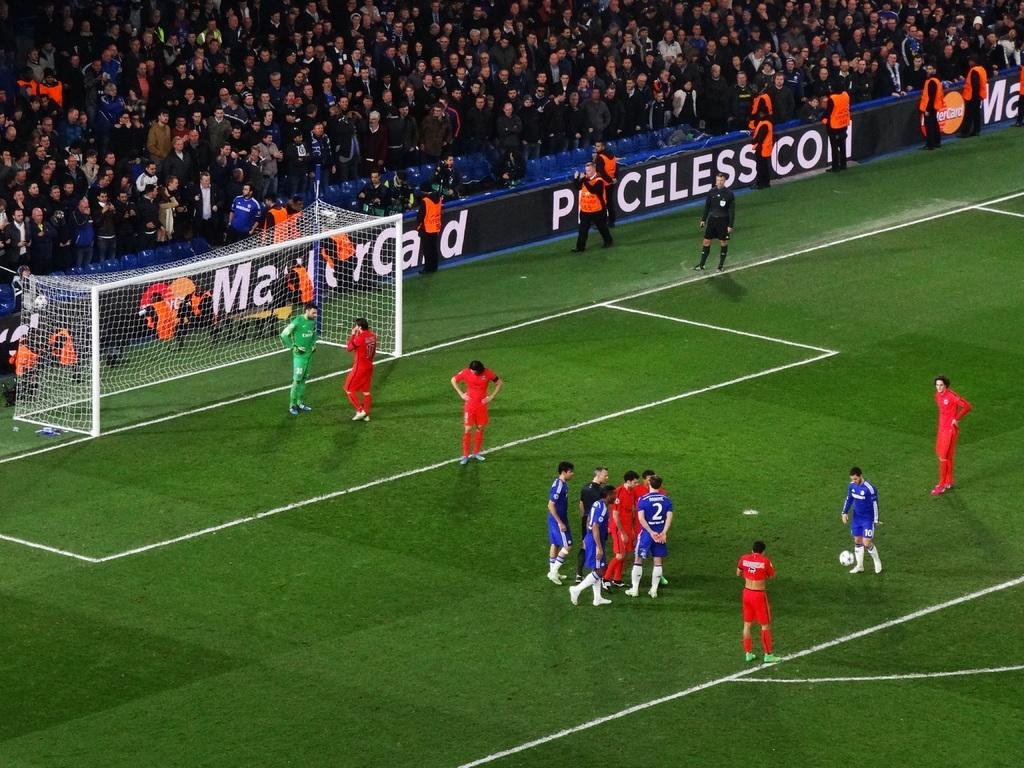What is happening on the ground in the image? There are players on the ground in the image. What can be seen in the background of the image? There are chairs and a crowd in the background of the image. What type of furniture is on fire in the image? There is no furniture present in the image, and therefore no such activity can be observed. Can you spot a rabbit in the image? There is no rabbit present in the image. 